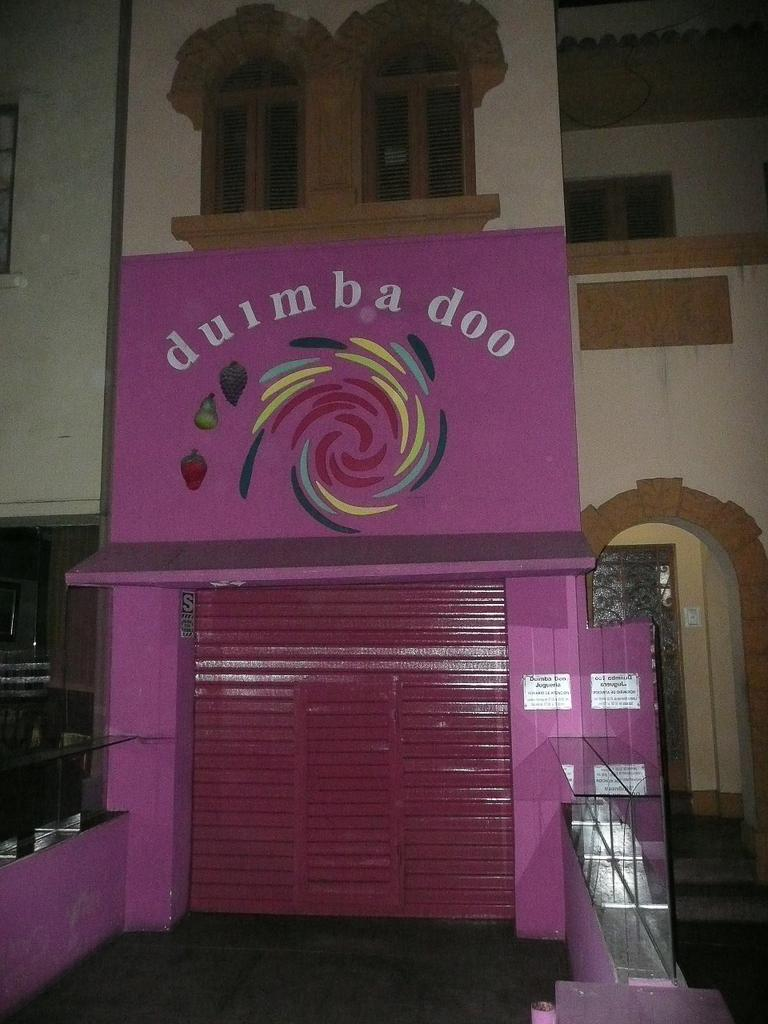What type of structure is present in the image? There is a building in the image. What color is the shutter on the building? The building has a pink shutter. Is there any signage on the building? Yes, there is a name board on the building. What are the walls made of in the building? The building has walls, but the material is not specified in the facts. How many windows can be seen on the building? The building has windows, but the exact number is not specified in the facts. What architectural feature is located on the right side of the image? There are stairs on the right side of the image. What type of vessel is being used to reduce friction in the image? There is no vessel or mention of friction in the image; it features a building with a pink shutter, a name board, walls, windows, and stairs. 